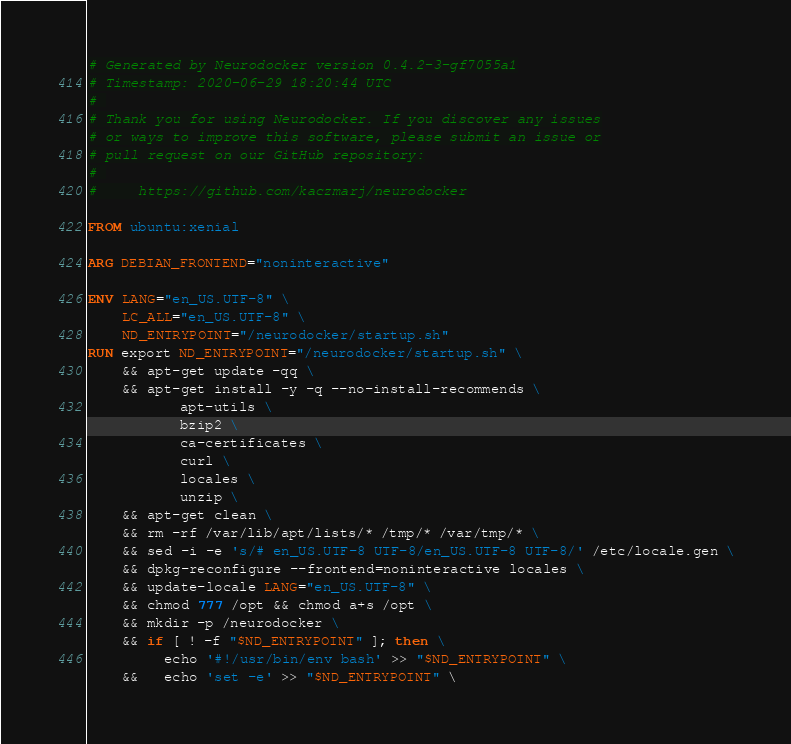Convert code to text. <code><loc_0><loc_0><loc_500><loc_500><_Dockerfile_># Generated by Neurodocker version 0.4.2-3-gf7055a1
# Timestamp: 2020-06-29 18:20:44 UTC
# 
# Thank you for using Neurodocker. If you discover any issues
# or ways to improve this software, please submit an issue or
# pull request on our GitHub repository:
# 
#     https://github.com/kaczmarj/neurodocker

FROM ubuntu:xenial

ARG DEBIAN_FRONTEND="noninteractive"

ENV LANG="en_US.UTF-8" \
    LC_ALL="en_US.UTF-8" \
    ND_ENTRYPOINT="/neurodocker/startup.sh"
RUN export ND_ENTRYPOINT="/neurodocker/startup.sh" \
    && apt-get update -qq \
    && apt-get install -y -q --no-install-recommends \
           apt-utils \
           bzip2 \
           ca-certificates \
           curl \
           locales \
           unzip \
    && apt-get clean \
    && rm -rf /var/lib/apt/lists/* /tmp/* /var/tmp/* \
    && sed -i -e 's/# en_US.UTF-8 UTF-8/en_US.UTF-8 UTF-8/' /etc/locale.gen \
    && dpkg-reconfigure --frontend=noninteractive locales \
    && update-locale LANG="en_US.UTF-8" \
    && chmod 777 /opt && chmod a+s /opt \
    && mkdir -p /neurodocker \
    && if [ ! -f "$ND_ENTRYPOINT" ]; then \
         echo '#!/usr/bin/env bash' >> "$ND_ENTRYPOINT" \
    &&   echo 'set -e' >> "$ND_ENTRYPOINT" \</code> 